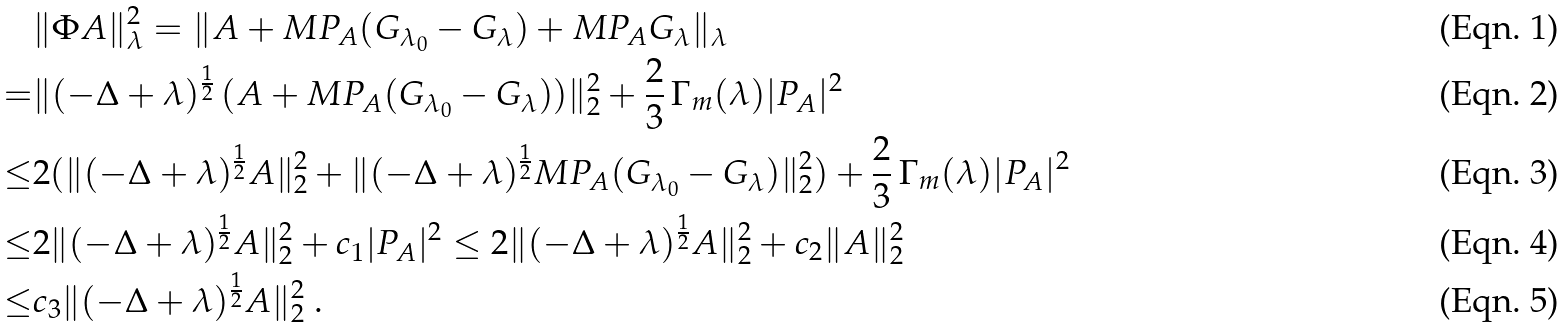Convert formula to latex. <formula><loc_0><loc_0><loc_500><loc_500>& \| \Phi A \| _ { \lambda } ^ { 2 } = \| A + M P _ { A } ( G _ { \lambda _ { 0 } } - G _ { \lambda } ) + M P _ { A } G _ { \lambda } \| _ { \lambda } \\ = & \| ( - \Delta + \lambda ) ^ { \frac { 1 } { 2 } } \, ( A + M P _ { A } ( G _ { \lambda _ { 0 } } - G _ { \lambda } ) ) \| ^ { 2 } _ { 2 } + \frac { 2 } { 3 } \, \Gamma _ { m } ( \lambda ) | P _ { A } | ^ { 2 } \\ \leq & 2 ( \| ( - \Delta + \lambda ) ^ { \frac { 1 } { 2 } } A \| ^ { 2 } _ { 2 } + \| ( - \Delta + \lambda ) ^ { \frac { 1 } { 2 } } M P _ { A } ( G _ { \lambda _ { 0 } } - G _ { \lambda } ) \| ^ { 2 } _ { 2 } ) + \frac { 2 } { 3 } \, \Gamma _ { m } ( \lambda ) | P _ { A } | ^ { 2 } \\ \leq & 2 \| ( - \Delta + \lambda ) ^ { \frac { 1 } { 2 } } A \| ^ { 2 } _ { 2 } + c _ { 1 } | P _ { A } | ^ { 2 } \leq 2 \| ( - \Delta + \lambda ) ^ { \frac { 1 } { 2 } } A \| ^ { 2 } _ { 2 } + c _ { 2 } \| A \| ^ { 2 } _ { 2 } \\ \leq & c _ { 3 } \| ( - \Delta + \lambda ) ^ { \frac { 1 } { 2 } } A \| ^ { 2 } _ { 2 } \ .</formula> 